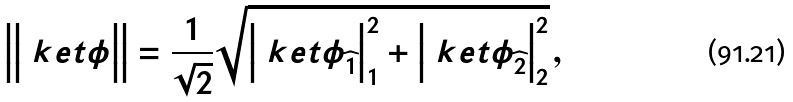Convert formula to latex. <formula><loc_0><loc_0><loc_500><loc_500>\Big { | } \Big { | } \ k e t { \phi } \Big { | } \Big { | } = \frac { 1 } { \sqrt { 2 } } \sqrt { \Big { | } \ k e t { \phi } _ { \widehat { 1 } } \Big { | } ^ { 2 } _ { 1 } + \Big { | } \ k e t { \phi } _ { \widehat { 2 } } \Big { | } ^ { 2 } _ { 2 } } \, ,</formula> 